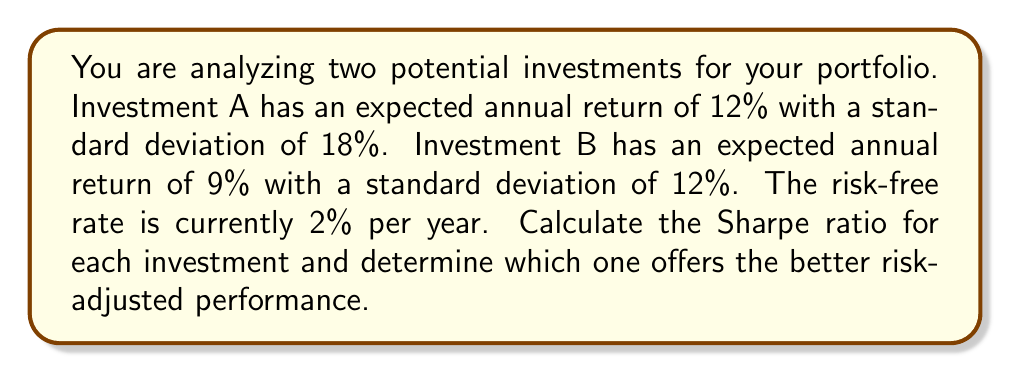Help me with this question. The Sharpe ratio is a measure of risk-adjusted performance, calculated as:

$$ \text{Sharpe Ratio} = \frac{R_p - R_f}{\sigma_p} $$

Where:
$R_p$ = Expected portfolio return
$R_f$ = Risk-free rate
$\sigma_p$ = Portfolio standard deviation

For Investment A:
$R_p = 12\%$
$R_f = 2\%$
$\sigma_p = 18\%$

Sharpe Ratio for A:
$$ \text{Sharpe Ratio}_A = \frac{0.12 - 0.02}{0.18} = \frac{0.10}{0.18} \approx 0.5556 $$

For Investment B:
$R_p = 9\%$
$R_f = 2\%$
$\sigma_p = 12\%$

Sharpe Ratio for B:
$$ \text{Sharpe Ratio}_B = \frac{0.09 - 0.02}{0.12} = \frac{0.07}{0.12} \approx 0.5833 $$

Investment B has a higher Sharpe ratio, indicating better risk-adjusted performance despite its lower expected return. This is because it offers a better return per unit of risk taken.
Answer: Investment A Sharpe Ratio: 0.5556
Investment B Sharpe Ratio: 0.5833
Investment B offers better risk-adjusted performance. 